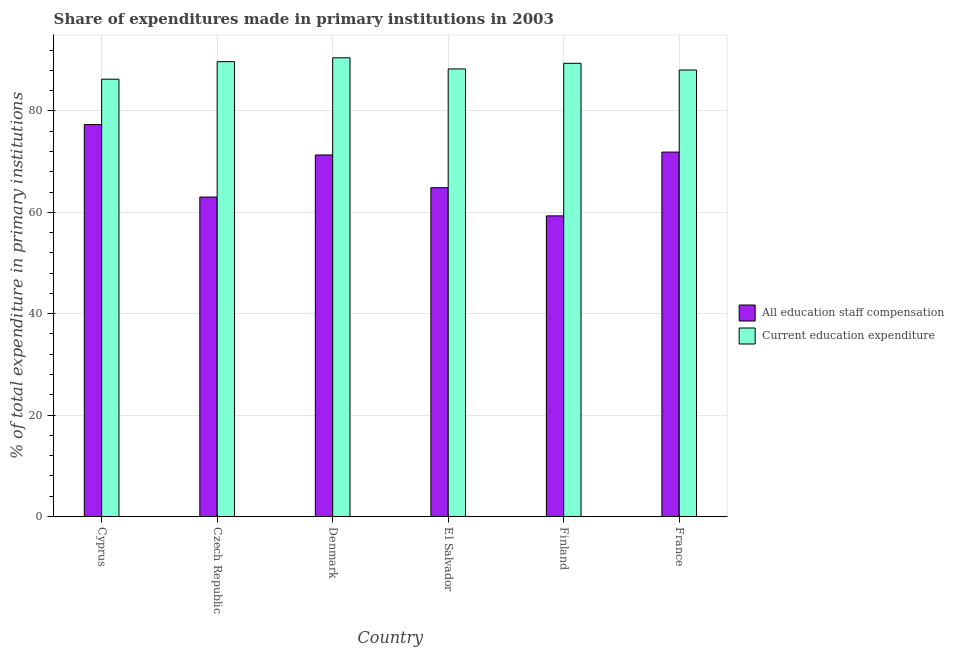How many different coloured bars are there?
Your response must be concise. 2. Are the number of bars on each tick of the X-axis equal?
Provide a succinct answer. Yes. How many bars are there on the 4th tick from the left?
Offer a terse response. 2. How many bars are there on the 1st tick from the right?
Make the answer very short. 2. What is the label of the 2nd group of bars from the left?
Your response must be concise. Czech Republic. What is the expenditure in education in Czech Republic?
Offer a terse response. 89.71. Across all countries, what is the maximum expenditure in education?
Make the answer very short. 90.47. Across all countries, what is the minimum expenditure in staff compensation?
Offer a terse response. 59.3. In which country was the expenditure in staff compensation minimum?
Offer a terse response. Finland. What is the total expenditure in education in the graph?
Your response must be concise. 532.17. What is the difference between the expenditure in education in Czech Republic and that in Finland?
Ensure brevity in your answer.  0.32. What is the difference between the expenditure in staff compensation in El Salvador and the expenditure in education in France?
Your response must be concise. -23.21. What is the average expenditure in education per country?
Make the answer very short. 88.69. What is the difference between the expenditure in education and expenditure in staff compensation in France?
Offer a terse response. 16.19. What is the ratio of the expenditure in education in Cyprus to that in Finland?
Offer a very short reply. 0.96. What is the difference between the highest and the second highest expenditure in education?
Your answer should be very brief. 0.76. What is the difference between the highest and the lowest expenditure in education?
Offer a terse response. 4.22. Is the sum of the expenditure in staff compensation in El Salvador and Finland greater than the maximum expenditure in education across all countries?
Keep it short and to the point. Yes. What does the 2nd bar from the left in Denmark represents?
Offer a very short reply. Current education expenditure. What does the 2nd bar from the right in El Salvador represents?
Offer a very short reply. All education staff compensation. Does the graph contain grids?
Provide a succinct answer. Yes. Where does the legend appear in the graph?
Make the answer very short. Center right. What is the title of the graph?
Your answer should be compact. Share of expenditures made in primary institutions in 2003. Does "Girls" appear as one of the legend labels in the graph?
Ensure brevity in your answer.  No. What is the label or title of the X-axis?
Your answer should be compact. Country. What is the label or title of the Y-axis?
Give a very brief answer. % of total expenditure in primary institutions. What is the % of total expenditure in primary institutions in All education staff compensation in Cyprus?
Provide a short and direct response. 77.3. What is the % of total expenditure in primary institutions in Current education expenditure in Cyprus?
Your answer should be very brief. 86.25. What is the % of total expenditure in primary institutions in All education staff compensation in Czech Republic?
Offer a terse response. 63.01. What is the % of total expenditure in primary institutions of Current education expenditure in Czech Republic?
Make the answer very short. 89.71. What is the % of total expenditure in primary institutions of All education staff compensation in Denmark?
Offer a very short reply. 71.31. What is the % of total expenditure in primary institutions in Current education expenditure in Denmark?
Provide a succinct answer. 90.47. What is the % of total expenditure in primary institutions of All education staff compensation in El Salvador?
Your response must be concise. 64.85. What is the % of total expenditure in primary institutions in Current education expenditure in El Salvador?
Give a very brief answer. 88.28. What is the % of total expenditure in primary institutions in All education staff compensation in Finland?
Keep it short and to the point. 59.3. What is the % of total expenditure in primary institutions of Current education expenditure in Finland?
Provide a short and direct response. 89.39. What is the % of total expenditure in primary institutions of All education staff compensation in France?
Your response must be concise. 71.88. What is the % of total expenditure in primary institutions in Current education expenditure in France?
Offer a very short reply. 88.06. Across all countries, what is the maximum % of total expenditure in primary institutions of All education staff compensation?
Make the answer very short. 77.3. Across all countries, what is the maximum % of total expenditure in primary institutions in Current education expenditure?
Your answer should be compact. 90.47. Across all countries, what is the minimum % of total expenditure in primary institutions of All education staff compensation?
Give a very brief answer. 59.3. Across all countries, what is the minimum % of total expenditure in primary institutions of Current education expenditure?
Provide a short and direct response. 86.25. What is the total % of total expenditure in primary institutions of All education staff compensation in the graph?
Make the answer very short. 407.65. What is the total % of total expenditure in primary institutions in Current education expenditure in the graph?
Offer a very short reply. 532.17. What is the difference between the % of total expenditure in primary institutions in All education staff compensation in Cyprus and that in Czech Republic?
Your answer should be compact. 14.3. What is the difference between the % of total expenditure in primary institutions in Current education expenditure in Cyprus and that in Czech Republic?
Make the answer very short. -3.46. What is the difference between the % of total expenditure in primary institutions of All education staff compensation in Cyprus and that in Denmark?
Make the answer very short. 5.99. What is the difference between the % of total expenditure in primary institutions in Current education expenditure in Cyprus and that in Denmark?
Your answer should be compact. -4.22. What is the difference between the % of total expenditure in primary institutions in All education staff compensation in Cyprus and that in El Salvador?
Your response must be concise. 12.45. What is the difference between the % of total expenditure in primary institutions in Current education expenditure in Cyprus and that in El Salvador?
Offer a very short reply. -2.03. What is the difference between the % of total expenditure in primary institutions in All education staff compensation in Cyprus and that in Finland?
Give a very brief answer. 18.01. What is the difference between the % of total expenditure in primary institutions in Current education expenditure in Cyprus and that in Finland?
Provide a succinct answer. -3.14. What is the difference between the % of total expenditure in primary institutions of All education staff compensation in Cyprus and that in France?
Your answer should be compact. 5.43. What is the difference between the % of total expenditure in primary institutions of Current education expenditure in Cyprus and that in France?
Your response must be concise. -1.81. What is the difference between the % of total expenditure in primary institutions of All education staff compensation in Czech Republic and that in Denmark?
Offer a terse response. -8.3. What is the difference between the % of total expenditure in primary institutions in Current education expenditure in Czech Republic and that in Denmark?
Keep it short and to the point. -0.76. What is the difference between the % of total expenditure in primary institutions of All education staff compensation in Czech Republic and that in El Salvador?
Your answer should be compact. -1.85. What is the difference between the % of total expenditure in primary institutions in Current education expenditure in Czech Republic and that in El Salvador?
Provide a short and direct response. 1.43. What is the difference between the % of total expenditure in primary institutions in All education staff compensation in Czech Republic and that in Finland?
Provide a short and direct response. 3.71. What is the difference between the % of total expenditure in primary institutions in Current education expenditure in Czech Republic and that in Finland?
Provide a succinct answer. 0.32. What is the difference between the % of total expenditure in primary institutions of All education staff compensation in Czech Republic and that in France?
Offer a very short reply. -8.87. What is the difference between the % of total expenditure in primary institutions in Current education expenditure in Czech Republic and that in France?
Make the answer very short. 1.65. What is the difference between the % of total expenditure in primary institutions of All education staff compensation in Denmark and that in El Salvador?
Give a very brief answer. 6.46. What is the difference between the % of total expenditure in primary institutions of Current education expenditure in Denmark and that in El Salvador?
Offer a terse response. 2.19. What is the difference between the % of total expenditure in primary institutions of All education staff compensation in Denmark and that in Finland?
Offer a terse response. 12.01. What is the difference between the % of total expenditure in primary institutions in All education staff compensation in Denmark and that in France?
Your response must be concise. -0.57. What is the difference between the % of total expenditure in primary institutions of Current education expenditure in Denmark and that in France?
Offer a very short reply. 2.41. What is the difference between the % of total expenditure in primary institutions of All education staff compensation in El Salvador and that in Finland?
Give a very brief answer. 5.56. What is the difference between the % of total expenditure in primary institutions of Current education expenditure in El Salvador and that in Finland?
Ensure brevity in your answer.  -1.11. What is the difference between the % of total expenditure in primary institutions in All education staff compensation in El Salvador and that in France?
Make the answer very short. -7.03. What is the difference between the % of total expenditure in primary institutions of Current education expenditure in El Salvador and that in France?
Ensure brevity in your answer.  0.22. What is the difference between the % of total expenditure in primary institutions in All education staff compensation in Finland and that in France?
Offer a very short reply. -12.58. What is the difference between the % of total expenditure in primary institutions in Current education expenditure in Finland and that in France?
Make the answer very short. 1.33. What is the difference between the % of total expenditure in primary institutions in All education staff compensation in Cyprus and the % of total expenditure in primary institutions in Current education expenditure in Czech Republic?
Your response must be concise. -12.41. What is the difference between the % of total expenditure in primary institutions in All education staff compensation in Cyprus and the % of total expenditure in primary institutions in Current education expenditure in Denmark?
Offer a terse response. -13.17. What is the difference between the % of total expenditure in primary institutions in All education staff compensation in Cyprus and the % of total expenditure in primary institutions in Current education expenditure in El Salvador?
Keep it short and to the point. -10.98. What is the difference between the % of total expenditure in primary institutions of All education staff compensation in Cyprus and the % of total expenditure in primary institutions of Current education expenditure in Finland?
Offer a very short reply. -12.08. What is the difference between the % of total expenditure in primary institutions of All education staff compensation in Cyprus and the % of total expenditure in primary institutions of Current education expenditure in France?
Provide a succinct answer. -10.76. What is the difference between the % of total expenditure in primary institutions in All education staff compensation in Czech Republic and the % of total expenditure in primary institutions in Current education expenditure in Denmark?
Make the answer very short. -27.47. What is the difference between the % of total expenditure in primary institutions of All education staff compensation in Czech Republic and the % of total expenditure in primary institutions of Current education expenditure in El Salvador?
Provide a succinct answer. -25.27. What is the difference between the % of total expenditure in primary institutions in All education staff compensation in Czech Republic and the % of total expenditure in primary institutions in Current education expenditure in Finland?
Your response must be concise. -26.38. What is the difference between the % of total expenditure in primary institutions of All education staff compensation in Czech Republic and the % of total expenditure in primary institutions of Current education expenditure in France?
Ensure brevity in your answer.  -25.06. What is the difference between the % of total expenditure in primary institutions of All education staff compensation in Denmark and the % of total expenditure in primary institutions of Current education expenditure in El Salvador?
Offer a very short reply. -16.97. What is the difference between the % of total expenditure in primary institutions of All education staff compensation in Denmark and the % of total expenditure in primary institutions of Current education expenditure in Finland?
Your answer should be very brief. -18.08. What is the difference between the % of total expenditure in primary institutions in All education staff compensation in Denmark and the % of total expenditure in primary institutions in Current education expenditure in France?
Offer a terse response. -16.75. What is the difference between the % of total expenditure in primary institutions of All education staff compensation in El Salvador and the % of total expenditure in primary institutions of Current education expenditure in Finland?
Offer a very short reply. -24.54. What is the difference between the % of total expenditure in primary institutions in All education staff compensation in El Salvador and the % of total expenditure in primary institutions in Current education expenditure in France?
Provide a short and direct response. -23.21. What is the difference between the % of total expenditure in primary institutions in All education staff compensation in Finland and the % of total expenditure in primary institutions in Current education expenditure in France?
Ensure brevity in your answer.  -28.77. What is the average % of total expenditure in primary institutions in All education staff compensation per country?
Offer a very short reply. 67.94. What is the average % of total expenditure in primary institutions of Current education expenditure per country?
Offer a very short reply. 88.69. What is the difference between the % of total expenditure in primary institutions in All education staff compensation and % of total expenditure in primary institutions in Current education expenditure in Cyprus?
Give a very brief answer. -8.95. What is the difference between the % of total expenditure in primary institutions of All education staff compensation and % of total expenditure in primary institutions of Current education expenditure in Czech Republic?
Ensure brevity in your answer.  -26.71. What is the difference between the % of total expenditure in primary institutions of All education staff compensation and % of total expenditure in primary institutions of Current education expenditure in Denmark?
Offer a terse response. -19.16. What is the difference between the % of total expenditure in primary institutions of All education staff compensation and % of total expenditure in primary institutions of Current education expenditure in El Salvador?
Give a very brief answer. -23.43. What is the difference between the % of total expenditure in primary institutions in All education staff compensation and % of total expenditure in primary institutions in Current education expenditure in Finland?
Offer a terse response. -30.09. What is the difference between the % of total expenditure in primary institutions of All education staff compensation and % of total expenditure in primary institutions of Current education expenditure in France?
Give a very brief answer. -16.19. What is the ratio of the % of total expenditure in primary institutions of All education staff compensation in Cyprus to that in Czech Republic?
Your response must be concise. 1.23. What is the ratio of the % of total expenditure in primary institutions of Current education expenditure in Cyprus to that in Czech Republic?
Offer a very short reply. 0.96. What is the ratio of the % of total expenditure in primary institutions in All education staff compensation in Cyprus to that in Denmark?
Make the answer very short. 1.08. What is the ratio of the % of total expenditure in primary institutions in Current education expenditure in Cyprus to that in Denmark?
Your answer should be compact. 0.95. What is the ratio of the % of total expenditure in primary institutions in All education staff compensation in Cyprus to that in El Salvador?
Ensure brevity in your answer.  1.19. What is the ratio of the % of total expenditure in primary institutions in Current education expenditure in Cyprus to that in El Salvador?
Keep it short and to the point. 0.98. What is the ratio of the % of total expenditure in primary institutions in All education staff compensation in Cyprus to that in Finland?
Give a very brief answer. 1.3. What is the ratio of the % of total expenditure in primary institutions in Current education expenditure in Cyprus to that in Finland?
Provide a short and direct response. 0.96. What is the ratio of the % of total expenditure in primary institutions of All education staff compensation in Cyprus to that in France?
Offer a very short reply. 1.08. What is the ratio of the % of total expenditure in primary institutions in Current education expenditure in Cyprus to that in France?
Offer a very short reply. 0.98. What is the ratio of the % of total expenditure in primary institutions of All education staff compensation in Czech Republic to that in Denmark?
Your response must be concise. 0.88. What is the ratio of the % of total expenditure in primary institutions in All education staff compensation in Czech Republic to that in El Salvador?
Your response must be concise. 0.97. What is the ratio of the % of total expenditure in primary institutions in Current education expenditure in Czech Republic to that in El Salvador?
Your answer should be compact. 1.02. What is the ratio of the % of total expenditure in primary institutions of All education staff compensation in Czech Republic to that in Finland?
Your answer should be very brief. 1.06. What is the ratio of the % of total expenditure in primary institutions of All education staff compensation in Czech Republic to that in France?
Your answer should be very brief. 0.88. What is the ratio of the % of total expenditure in primary institutions in Current education expenditure in Czech Republic to that in France?
Provide a succinct answer. 1.02. What is the ratio of the % of total expenditure in primary institutions in All education staff compensation in Denmark to that in El Salvador?
Give a very brief answer. 1.1. What is the ratio of the % of total expenditure in primary institutions of Current education expenditure in Denmark to that in El Salvador?
Keep it short and to the point. 1.02. What is the ratio of the % of total expenditure in primary institutions of All education staff compensation in Denmark to that in Finland?
Provide a succinct answer. 1.2. What is the ratio of the % of total expenditure in primary institutions in Current education expenditure in Denmark to that in Finland?
Keep it short and to the point. 1.01. What is the ratio of the % of total expenditure in primary institutions in All education staff compensation in Denmark to that in France?
Make the answer very short. 0.99. What is the ratio of the % of total expenditure in primary institutions of Current education expenditure in Denmark to that in France?
Make the answer very short. 1.03. What is the ratio of the % of total expenditure in primary institutions in All education staff compensation in El Salvador to that in Finland?
Your answer should be very brief. 1.09. What is the ratio of the % of total expenditure in primary institutions of Current education expenditure in El Salvador to that in Finland?
Provide a short and direct response. 0.99. What is the ratio of the % of total expenditure in primary institutions in All education staff compensation in El Salvador to that in France?
Offer a terse response. 0.9. What is the ratio of the % of total expenditure in primary institutions in All education staff compensation in Finland to that in France?
Your answer should be very brief. 0.82. What is the ratio of the % of total expenditure in primary institutions in Current education expenditure in Finland to that in France?
Provide a short and direct response. 1.02. What is the difference between the highest and the second highest % of total expenditure in primary institutions in All education staff compensation?
Offer a very short reply. 5.43. What is the difference between the highest and the second highest % of total expenditure in primary institutions in Current education expenditure?
Provide a short and direct response. 0.76. What is the difference between the highest and the lowest % of total expenditure in primary institutions in All education staff compensation?
Your response must be concise. 18.01. What is the difference between the highest and the lowest % of total expenditure in primary institutions of Current education expenditure?
Offer a very short reply. 4.22. 